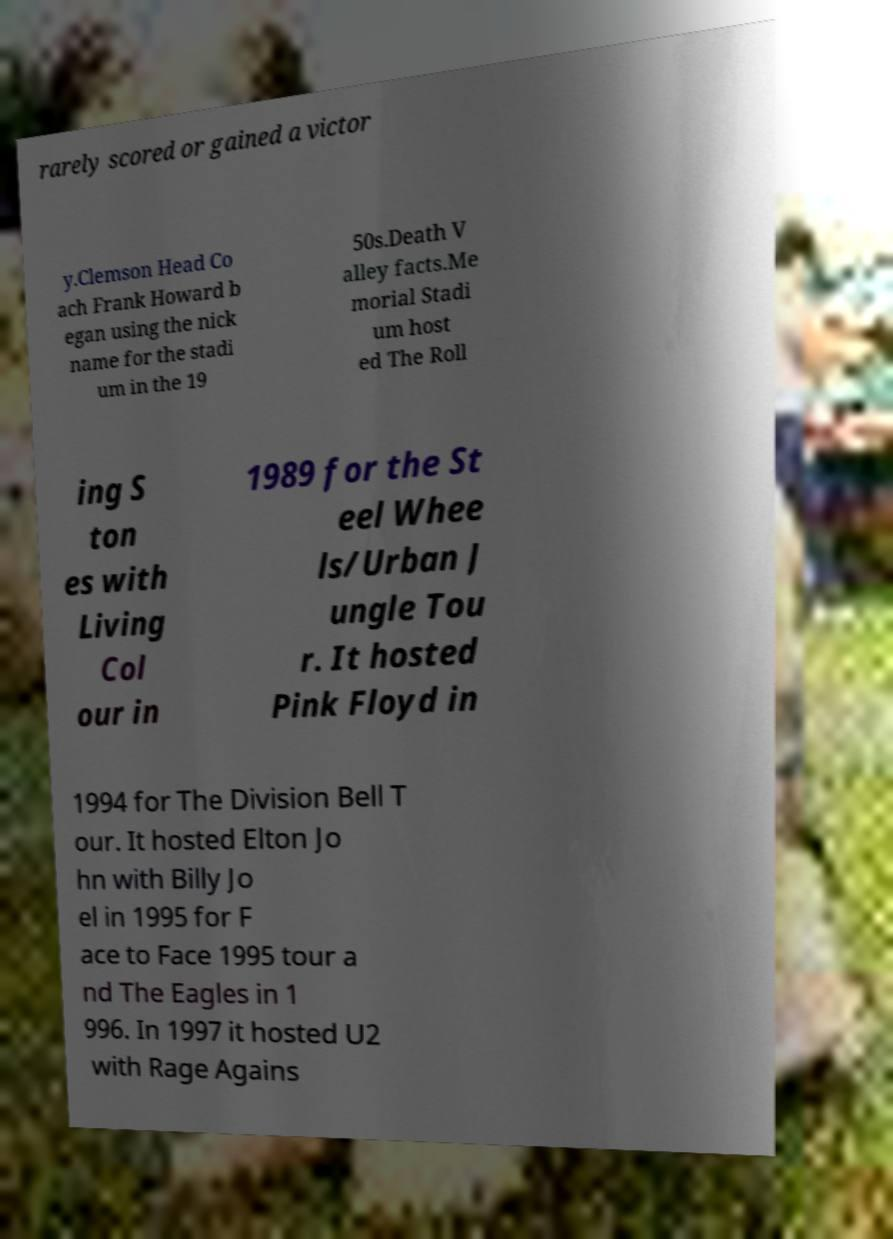Could you assist in decoding the text presented in this image and type it out clearly? rarely scored or gained a victor y.Clemson Head Co ach Frank Howard b egan using the nick name for the stadi um in the 19 50s.Death V alley facts.Me morial Stadi um host ed The Roll ing S ton es with Living Col our in 1989 for the St eel Whee ls/Urban J ungle Tou r. It hosted Pink Floyd in 1994 for The Division Bell T our. It hosted Elton Jo hn with Billy Jo el in 1995 for F ace to Face 1995 tour a nd The Eagles in 1 996. In 1997 it hosted U2 with Rage Agains 